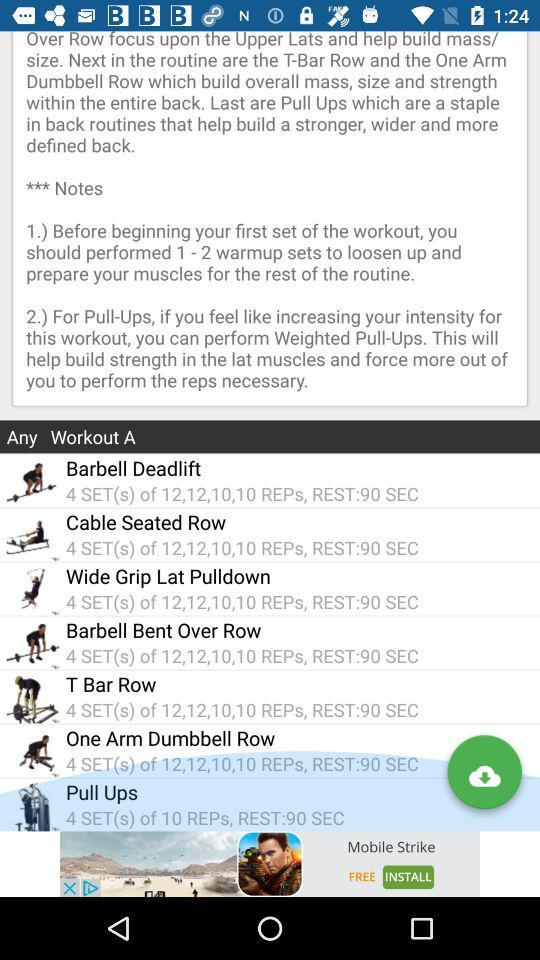What is the rest time for pull ups? The rest time is 90 seconds. 